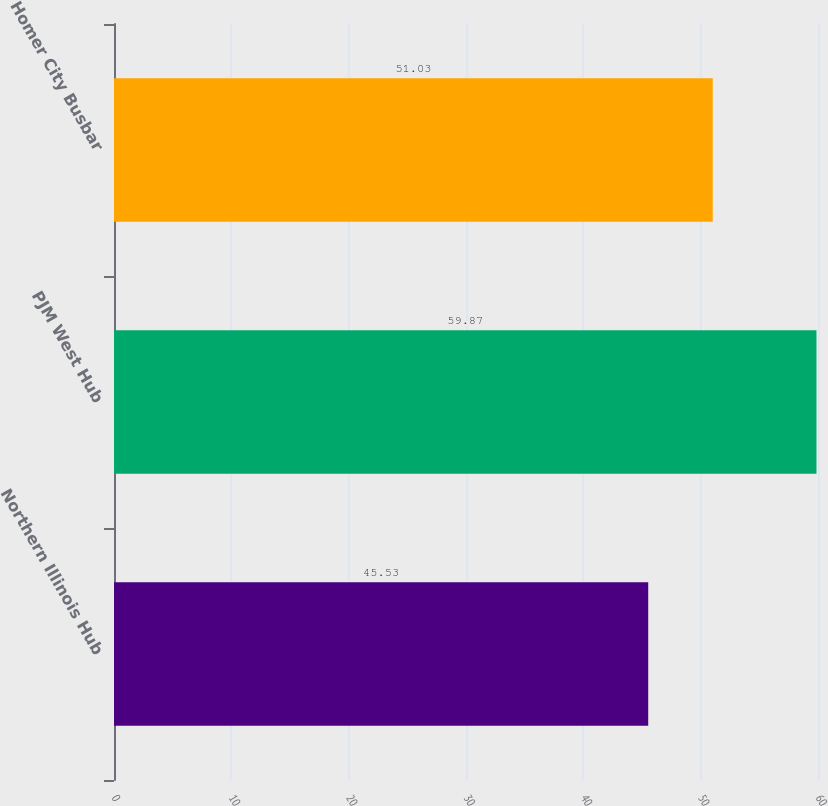Convert chart. <chart><loc_0><loc_0><loc_500><loc_500><bar_chart><fcel>Northern Illinois Hub<fcel>PJM West Hub<fcel>Homer City Busbar<nl><fcel>45.53<fcel>59.87<fcel>51.03<nl></chart> 